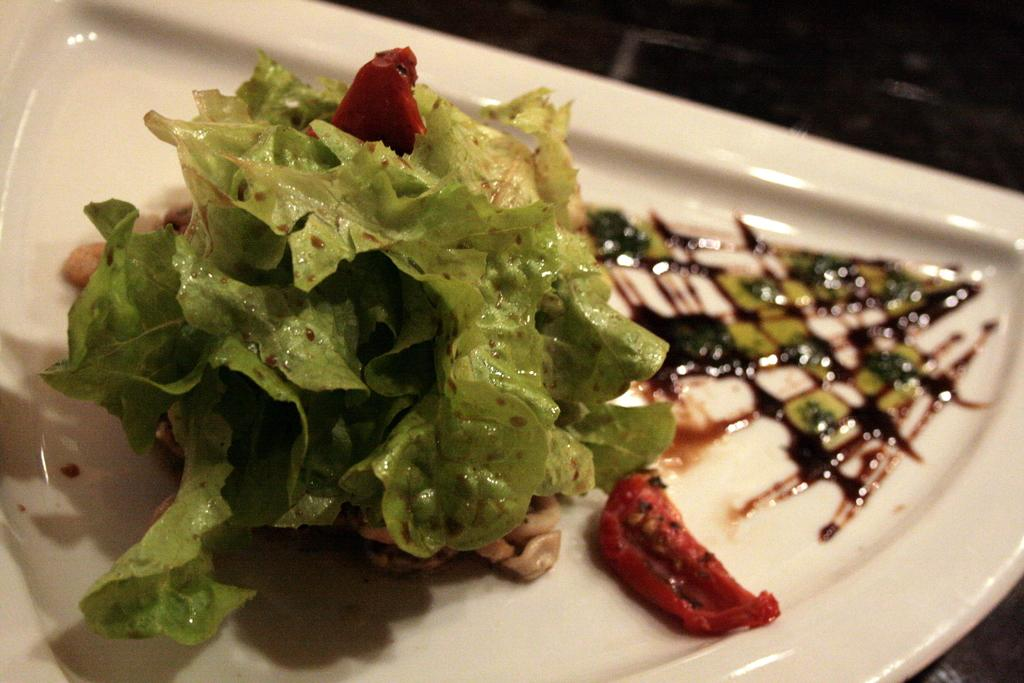What is present on the plate in the image? There is a food item on the plate in the image. Can you describe the food item on the plate? Unfortunately, the specific food item cannot be determined from the provided facts. What color are the babies in the image? There are no babies present in the image. 